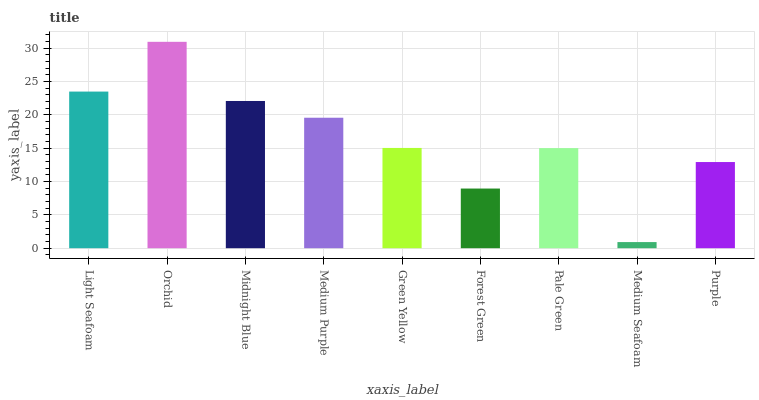Is Midnight Blue the minimum?
Answer yes or no. No. Is Midnight Blue the maximum?
Answer yes or no. No. Is Orchid greater than Midnight Blue?
Answer yes or no. Yes. Is Midnight Blue less than Orchid?
Answer yes or no. Yes. Is Midnight Blue greater than Orchid?
Answer yes or no. No. Is Orchid less than Midnight Blue?
Answer yes or no. No. Is Green Yellow the high median?
Answer yes or no. Yes. Is Green Yellow the low median?
Answer yes or no. Yes. Is Purple the high median?
Answer yes or no. No. Is Medium Purple the low median?
Answer yes or no. No. 